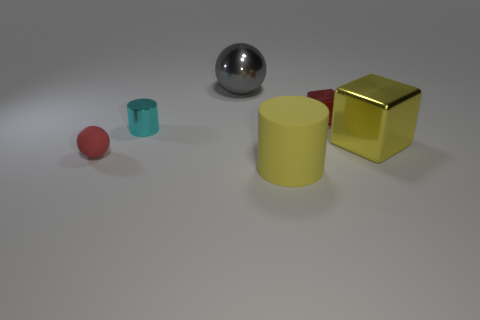There is a yellow object in front of the large yellow metal block; does it have the same size as the red thing that is in front of the cyan cylinder?
Your answer should be very brief. No. How many other things are the same shape as the cyan shiny thing?
Ensure brevity in your answer.  1. The ball that is behind the object that is to the left of the cyan metal cylinder is made of what material?
Offer a terse response. Metal. How many shiny things are either tiny brown cubes or cyan things?
Keep it short and to the point. 1. Are there any other things that are made of the same material as the large gray object?
Provide a short and direct response. Yes. Is there a big yellow shiny block that is in front of the thing in front of the tiny red ball?
Your answer should be very brief. No. How many objects are small red objects on the left side of the yellow matte cylinder or red rubber spheres on the left side of the yellow matte thing?
Provide a succinct answer. 1. Are there any other things of the same color as the large shiny cube?
Your answer should be very brief. Yes. The large shiny sphere that is behind the cube to the left of the yellow thing that is behind the rubber sphere is what color?
Provide a short and direct response. Gray. There is a cylinder that is in front of the large yellow object to the right of the big rubber thing; what size is it?
Provide a succinct answer. Large. 